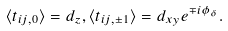Convert formula to latex. <formula><loc_0><loc_0><loc_500><loc_500>\langle t _ { i j , 0 } \rangle = d _ { z } , \langle t _ { i j , \pm 1 } \rangle = d _ { x y } e ^ { \mp i \phi _ { \delta } } .</formula> 